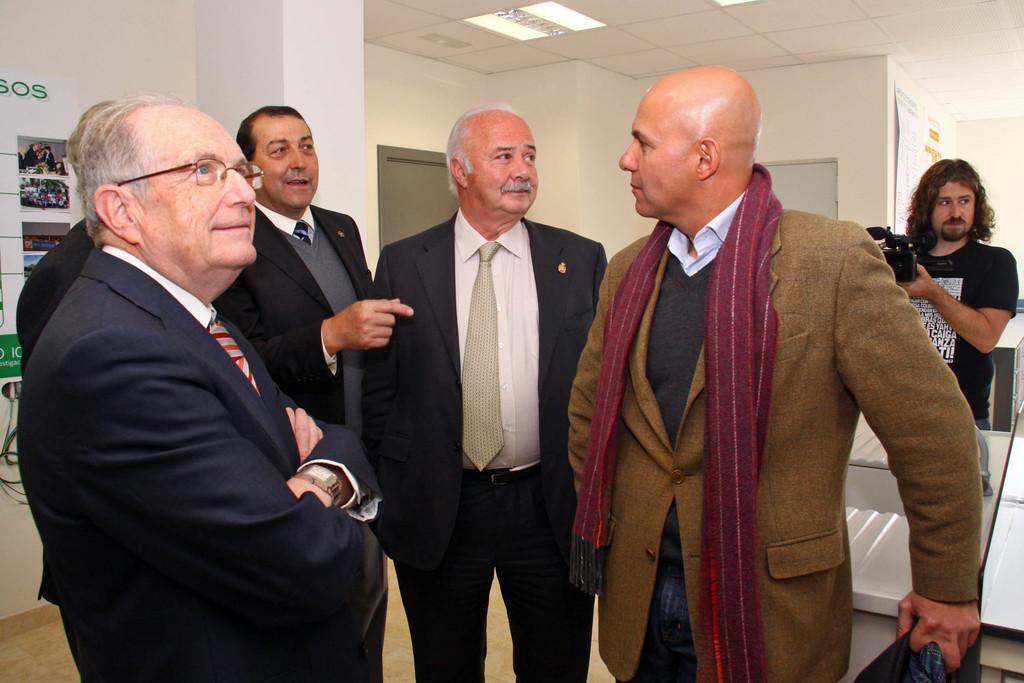Can you describe this image briefly? In this image we can see five men standing on the floor. They are wearing a suit and a tie. Here we can see a scarf. Here we can see a man and looks like he is speaking. Here we can see a man on the right side. He is wearing a black color T-shirt and he is holding the camera in his hands. Here we can see the lighting arrangement on the roof. 